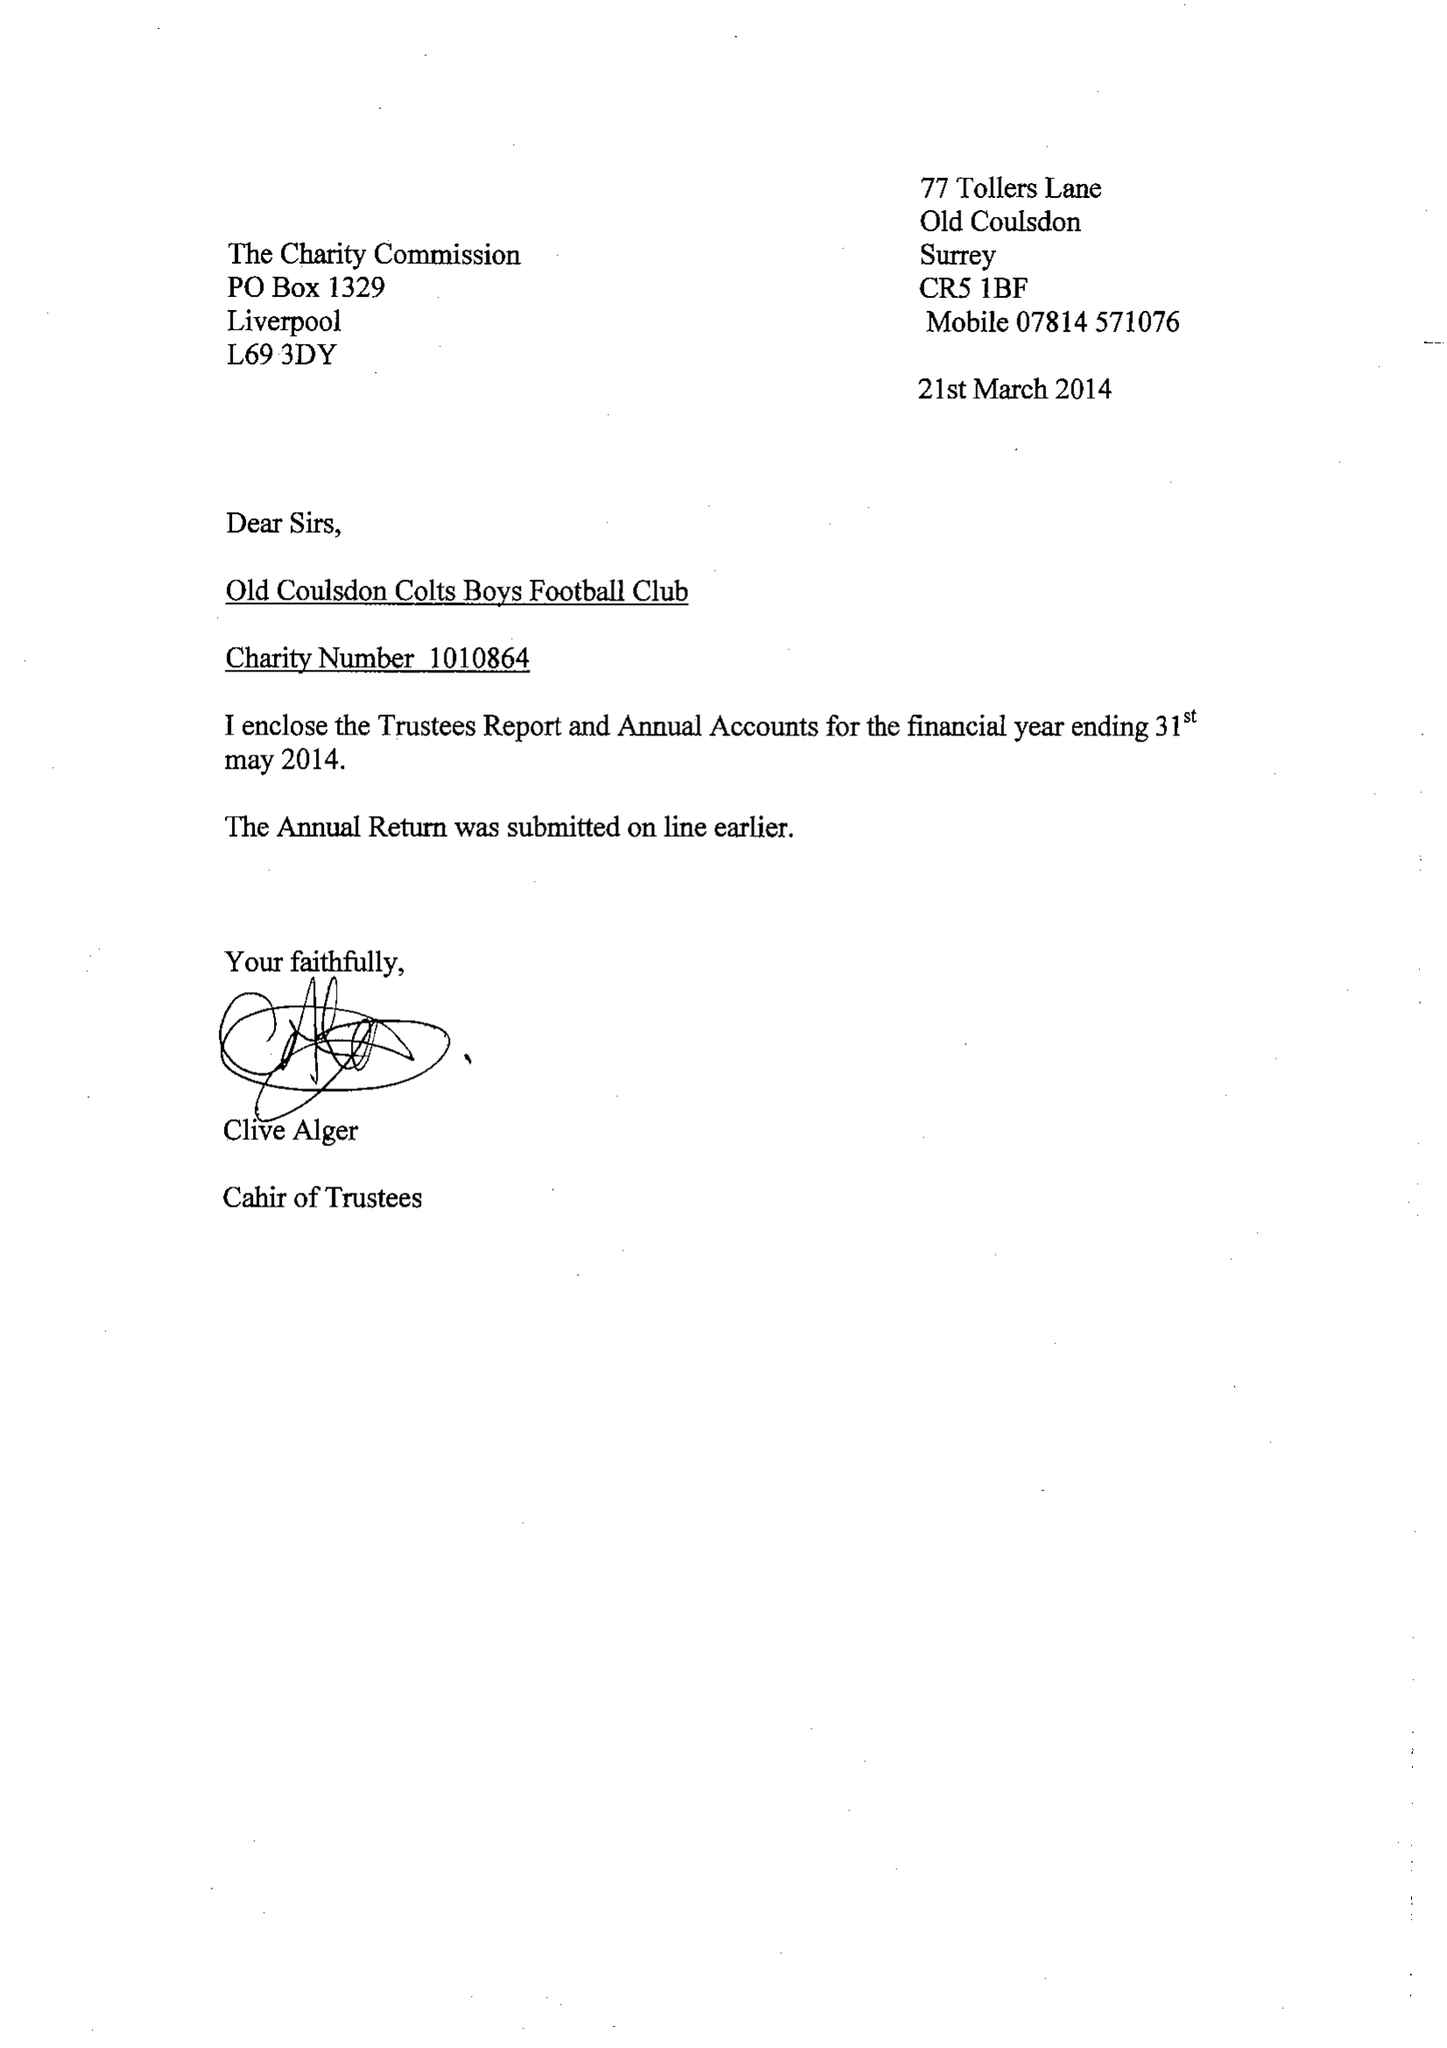What is the value for the address__street_line?
Answer the question using a single word or phrase. 77 TOLLERS LANE 